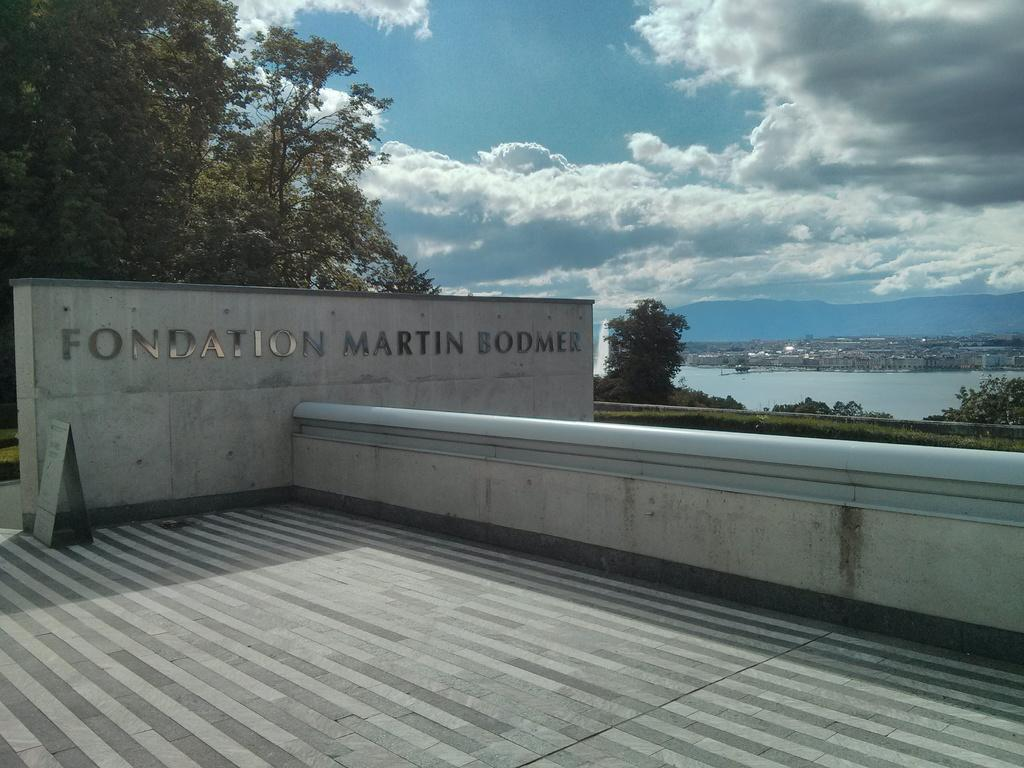What is present on the wall in the image? There is text on the wall in the image. What type of natural environment can be seen in the image? Trees and water are visible in the image. What is the condition of the sky in the image? The sky is cloudy in the image. What is the surface beneath the wall in the image? There is a floor in the image. What scent can be detected from the locket in the image? There is no locket present in the image, so it is not possible to detect a scent. 